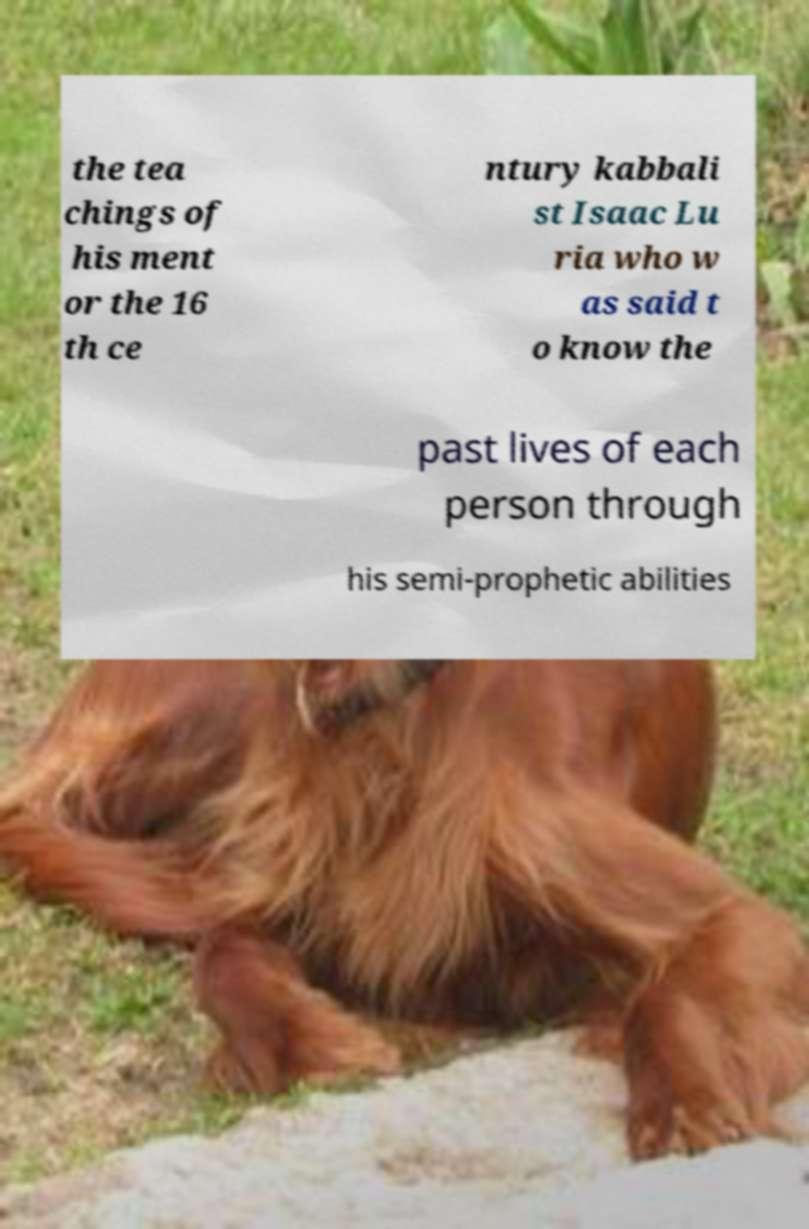Can you read and provide the text displayed in the image?This photo seems to have some interesting text. Can you extract and type it out for me? the tea chings of his ment or the 16 th ce ntury kabbali st Isaac Lu ria who w as said t o know the past lives of each person through his semi-prophetic abilities 